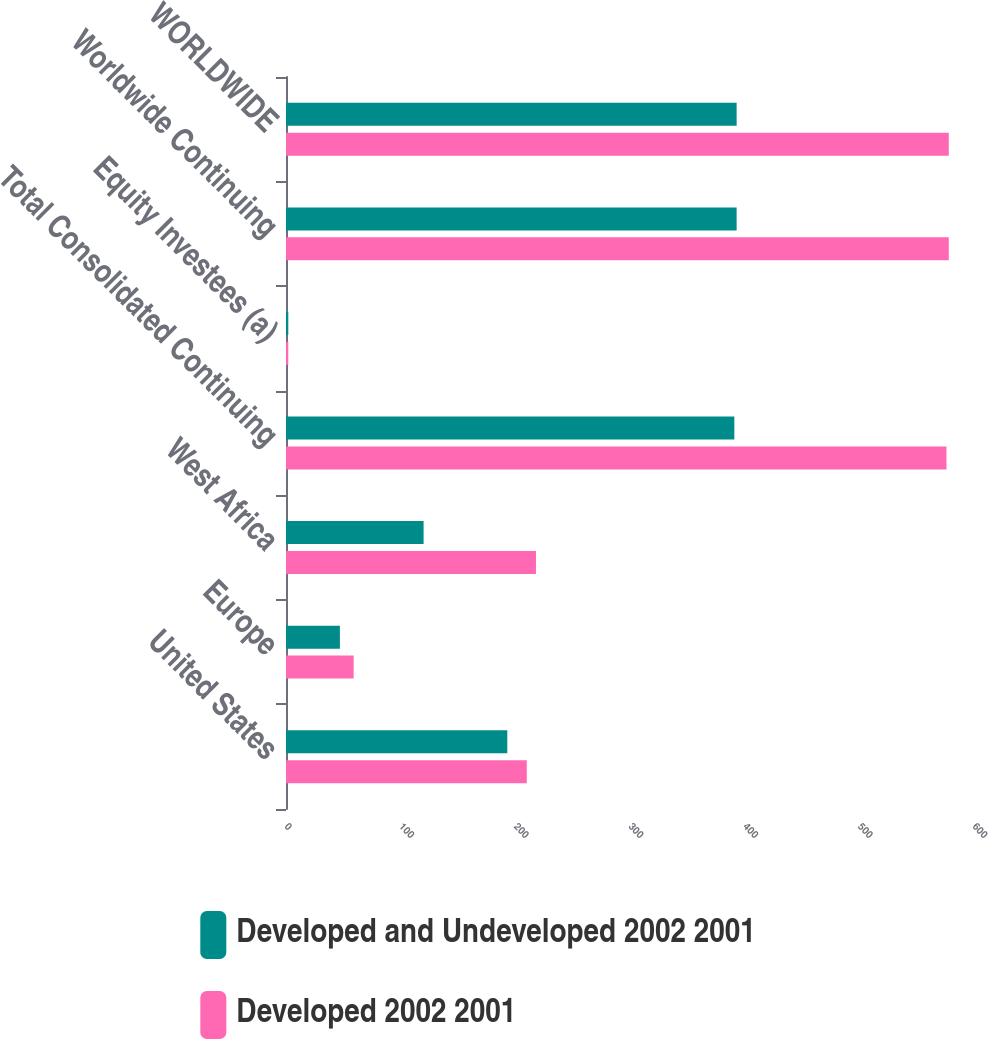Convert chart. <chart><loc_0><loc_0><loc_500><loc_500><stacked_bar_chart><ecel><fcel>United States<fcel>Europe<fcel>West Africa<fcel>Total Consolidated Continuing<fcel>Equity Investees (a)<fcel>Worldwide Continuing<fcel>WORLDWIDE<nl><fcel>Developed and Undeveloped 2002 2001<fcel>193<fcel>47<fcel>120<fcel>391<fcel>2<fcel>393<fcel>393<nl><fcel>Developed 2002 2001<fcel>210<fcel>59<fcel>218<fcel>576<fcel>2<fcel>578<fcel>578<nl></chart> 